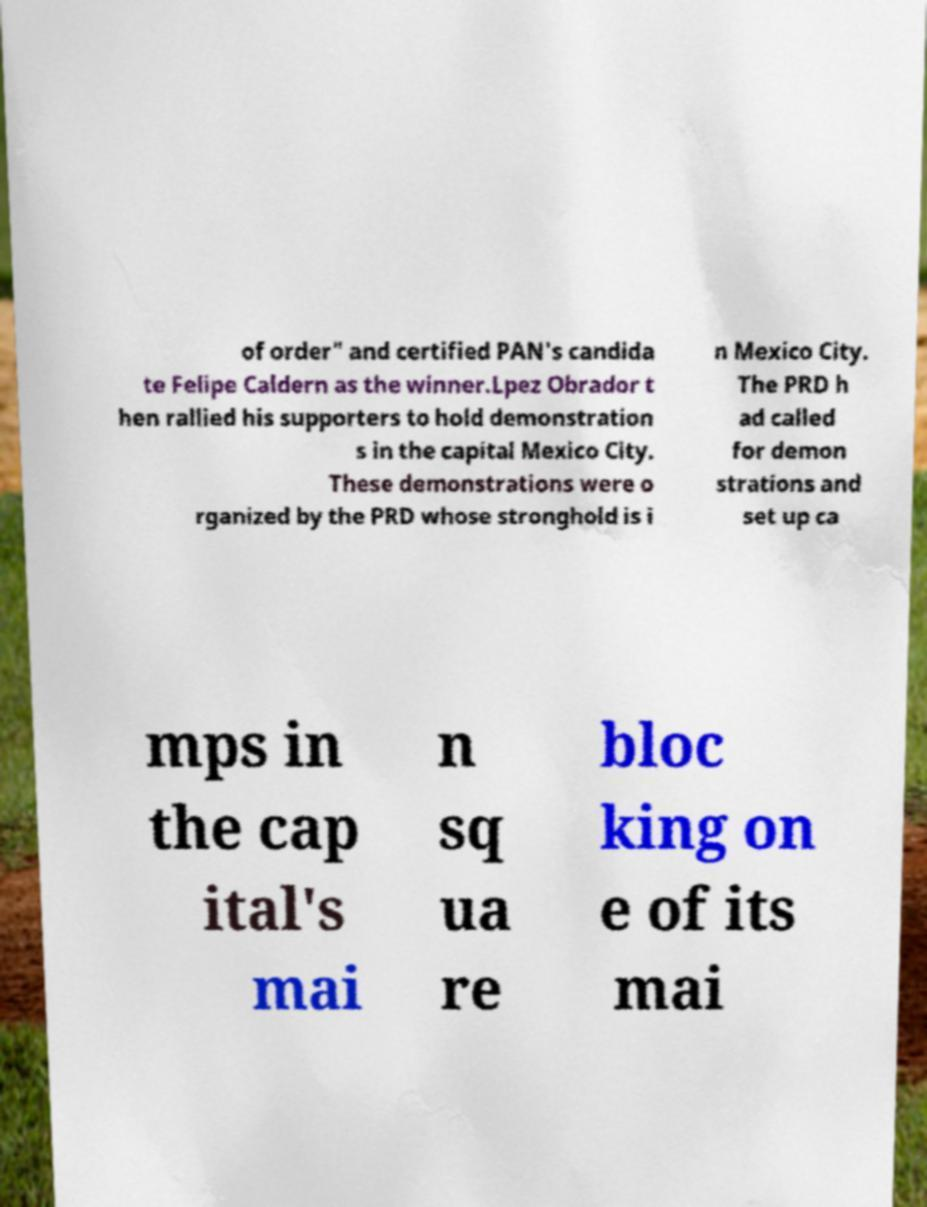Can you accurately transcribe the text from the provided image for me? of order" and certified PAN's candida te Felipe Caldern as the winner.Lpez Obrador t hen rallied his supporters to hold demonstration s in the capital Mexico City. These demonstrations were o rganized by the PRD whose stronghold is i n Mexico City. The PRD h ad called for demon strations and set up ca mps in the cap ital's mai n sq ua re bloc king on e of its mai 